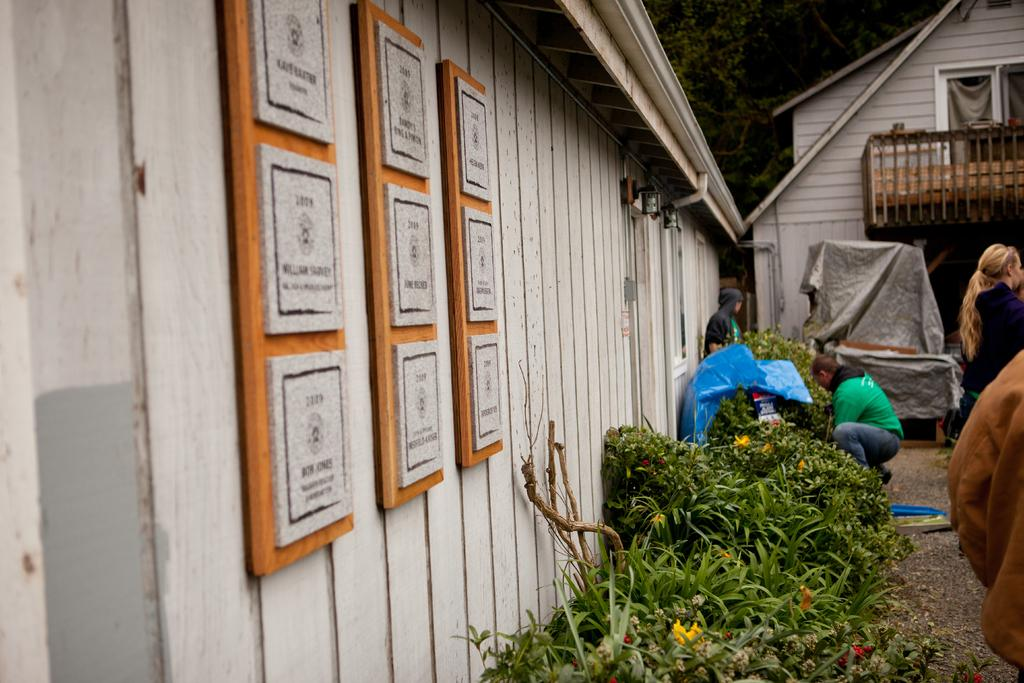What types of structures are visible in the image? There are buildings in the image. What other elements can be seen in the image besides the buildings? There are plants and people visible in the image. What can be seen in the background of the image? There are trees in the background of the image. What type of kitty can be seen climbing the zinc system in the image? There is no kitty or zinc system present in the image. 